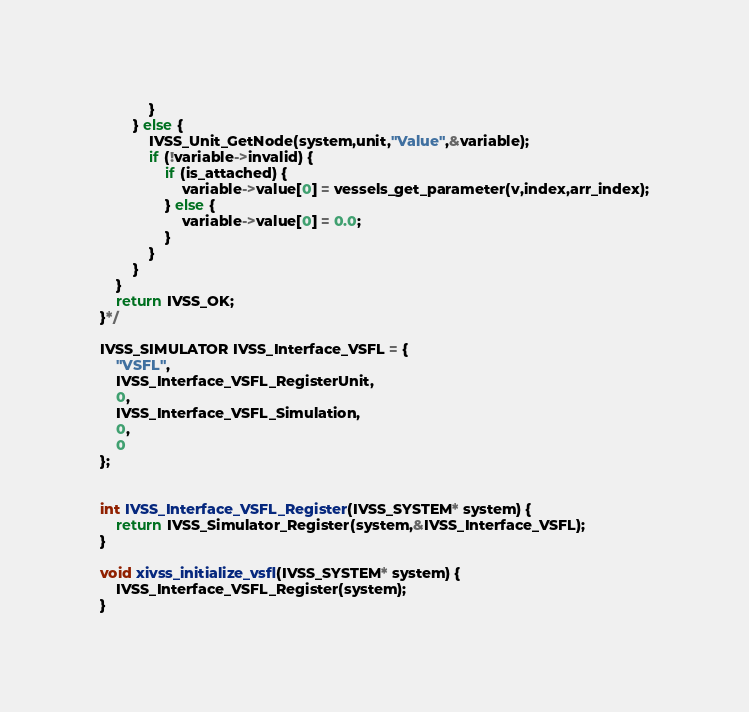<code> <loc_0><loc_0><loc_500><loc_500><_C_>			}
		} else {
			IVSS_Unit_GetNode(system,unit,"Value",&variable);
			if (!variable->invalid) {
				if (is_attached) {
					variable->value[0] = vessels_get_parameter(v,index,arr_index);
				} else {
					variable->value[0] = 0.0;
				}
			}
		}
	}
	return IVSS_OK;
}*/

IVSS_SIMULATOR IVSS_Interface_VSFL = {
	"VSFL",
	IVSS_Interface_VSFL_RegisterUnit,
	0,
	IVSS_Interface_VSFL_Simulation,
	0,
	0
};


int IVSS_Interface_VSFL_Register(IVSS_SYSTEM* system) {
	return IVSS_Simulator_Register(system,&IVSS_Interface_VSFL);
}

void xivss_initialize_vsfl(IVSS_SYSTEM* system) {
	IVSS_Interface_VSFL_Register(system);
}</code> 